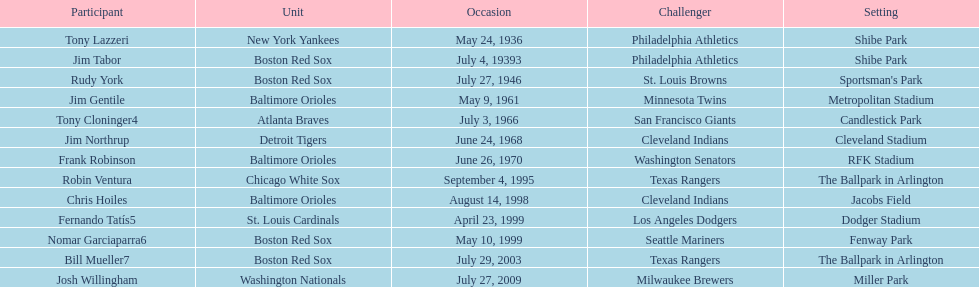What are the dates? May 24, 1936, July 4, 19393, July 27, 1946, May 9, 1961, July 3, 1966, June 24, 1968, June 26, 1970, September 4, 1995, August 14, 1998, April 23, 1999, May 10, 1999, July 29, 2003, July 27, 2009. Which date is in 1936? May 24, 1936. What player is listed for this date? Tony Lazzeri. 